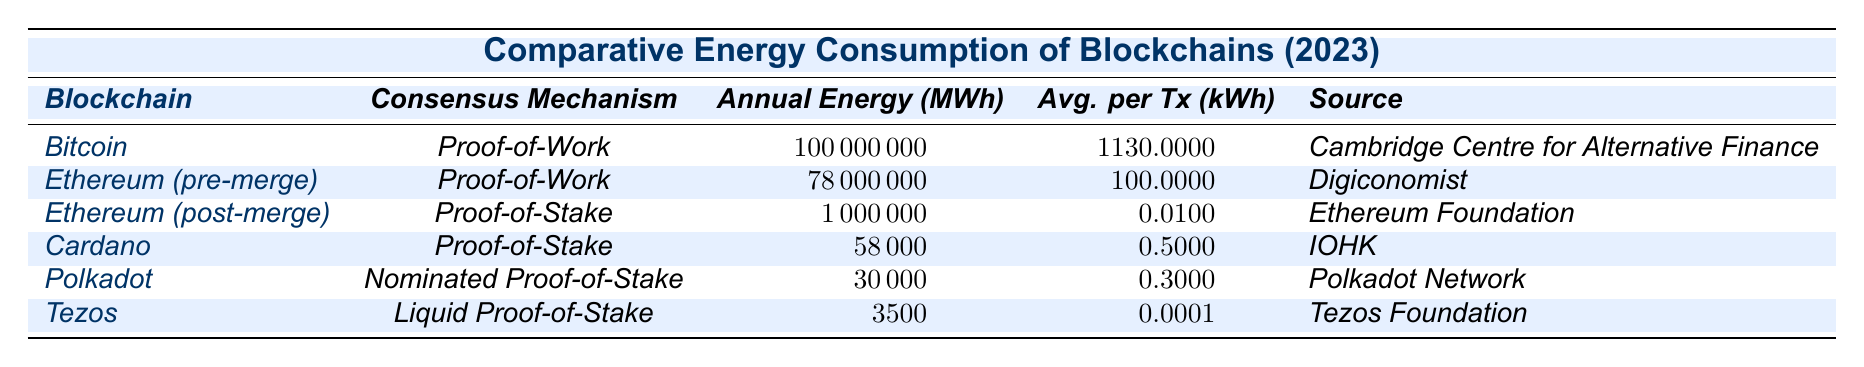What is the annual energy consumption of Bitcoin? The table lists the annual energy consumption for Bitcoin, which is given as 100,000,000 MWh.
Answer: 100,000,000 MWh Which blockchain has the highest average energy consumption per transaction? By examining the average energy consumption per transaction column, Bitcoin shows the highest value at 1130 kWh.
Answer: Bitcoin How much less annual energy does Ethereum (post-merge) consume compared to Ethereum (pre-merge)? Ethereum (pre-merge) consumes 78,000,000 MWh and Ethereum (post-merge) consumes 1,000,000 MWh. The difference is 78,000,000 MWh - 1,000,000 MWh = 77,000,000 MWh.
Answer: 77,000,000 MWh Is the average energy consumption per transaction for Tezos lower than 1 kWh? The average energy consumption per transaction for Tezos is 0.0001 kWh, which is indeed lower than 1 kWh.
Answer: Yes What is the total annual energy consumption of all Proof-of-Stake blockchains listed? Ethereum (post-merge) = 1,000,000 MWh, Cardano = 58,000 MWh, Polkadot = 30,000 MWh, and Tezos = 3,500 MWh. Summing these gives 1,000,000 + 58,000 + 30,000 + 3,500 = 1,091,500 MWh in total.
Answer: 1,091,500 MWh How does the annual energy consumption of Cardano compare to Polkadot? Cardano consumes 58,000 MWh annually, while Polkadot consumes 30,000 MWh. Therefore, Cardano consumes more by 58,000 MWh - 30,000 MWh = 28,000 MWh.
Answer: Cardano consumes 28,000 MWh more than Polkadot Which consensus mechanism blockchain has the lowest average energy consumption per transaction? Looking at the average energy consumption per transaction, Tezos shows the lowest at 0.0001 kWh.
Answer: Tezos What is the average annual energy consumption of all the blockchains listed in the table? To find the average, first sum the annual consumption: 100,000,000 + 78,000,000 + 1,000,000 + 58,000 + 30,000 + 3,500 = 179,171,500 MWh. Then divide by the number of blockchains (6): 179,171,500 MWh / 6 = 29,862,583.33 MWh.
Answer: 29,862,583.33 MWh Is the total energy consumption of all Proof-of-Work blockchains greater than that of all Proof-of-Stake blockchains combined? The total for Proof-of-Work (Bitcoin + Ethereum pre-merge) is 100,000,000 + 78,000,000 = 178,000,000 MWh. For Proof-of-Stake (post-merge, Cardano, Polkadot, Tezos), it totals 1,000,000 + 58,000 + 30,000 + 3,500 = 1,091,500 MWh. Hence, 178,000,000 MWh > 1,091,500 MWh, so yes.
Answer: Yes What is the consensus mechanism for the blockchain with the lowest annual energy consumption? The blockchain with the lowest annual energy consumption is Tezos at 3,500 MWh, and its consensus mechanism is Liquid Proof-of-Stake.
Answer: Liquid Proof-of-Stake 